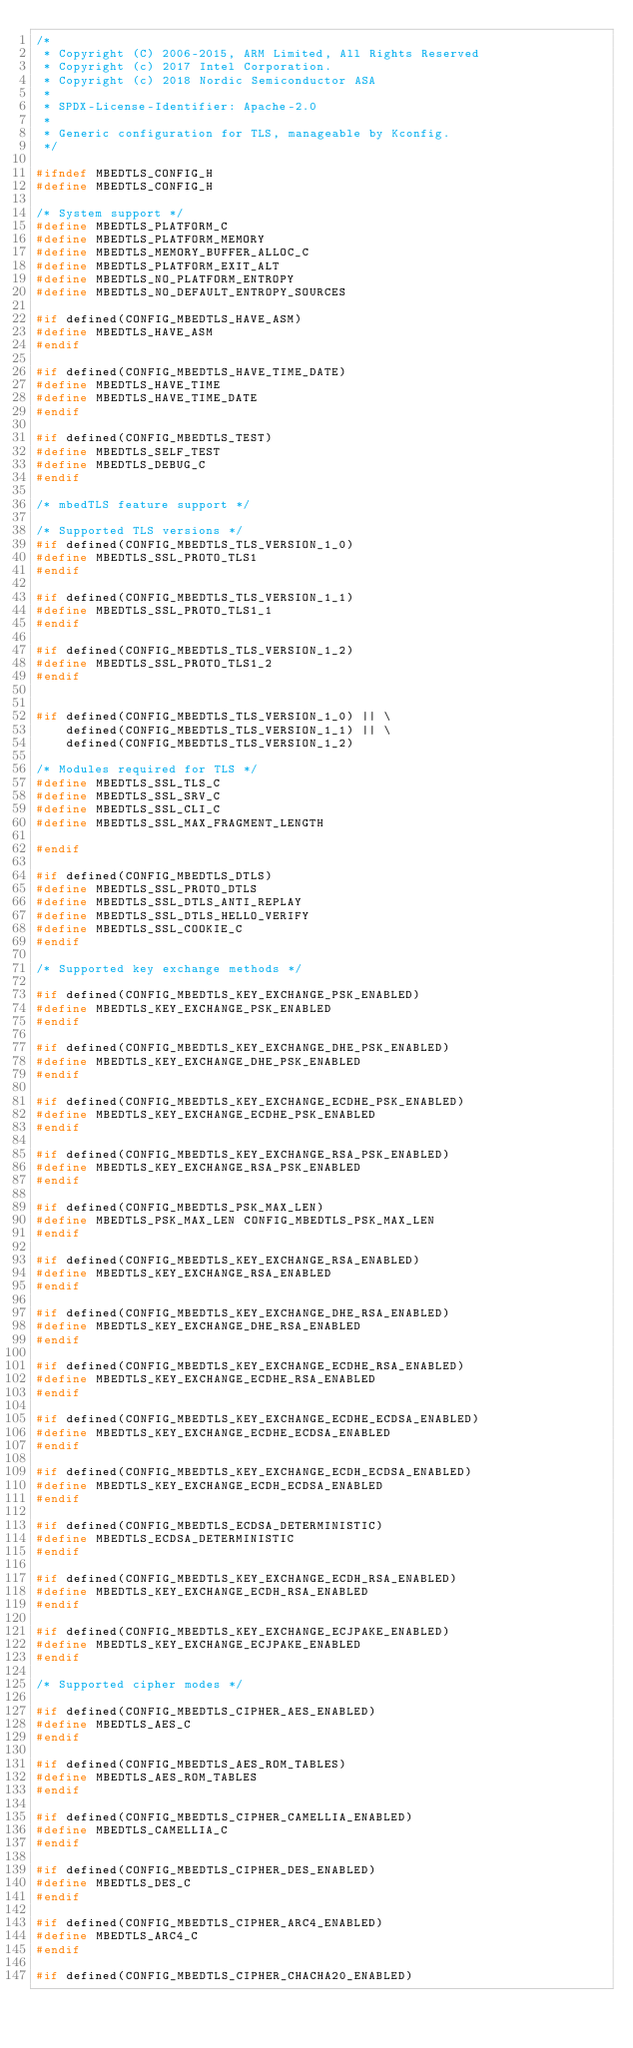Convert code to text. <code><loc_0><loc_0><loc_500><loc_500><_C_>/*
 * Copyright (C) 2006-2015, ARM Limited, All Rights Reserved
 * Copyright (c) 2017 Intel Corporation.
 * Copyright (c) 2018 Nordic Semiconductor ASA
 *
 * SPDX-License-Identifier: Apache-2.0
 *
 * Generic configuration for TLS, manageable by Kconfig.
 */

#ifndef MBEDTLS_CONFIG_H
#define MBEDTLS_CONFIG_H

/* System support */
#define MBEDTLS_PLATFORM_C
#define MBEDTLS_PLATFORM_MEMORY
#define MBEDTLS_MEMORY_BUFFER_ALLOC_C
#define MBEDTLS_PLATFORM_EXIT_ALT
#define MBEDTLS_NO_PLATFORM_ENTROPY
#define MBEDTLS_NO_DEFAULT_ENTROPY_SOURCES

#if defined(CONFIG_MBEDTLS_HAVE_ASM)
#define MBEDTLS_HAVE_ASM
#endif

#if defined(CONFIG_MBEDTLS_HAVE_TIME_DATE)
#define MBEDTLS_HAVE_TIME
#define MBEDTLS_HAVE_TIME_DATE
#endif

#if defined(CONFIG_MBEDTLS_TEST)
#define MBEDTLS_SELF_TEST
#define MBEDTLS_DEBUG_C
#endif

/* mbedTLS feature support */

/* Supported TLS versions */
#if defined(CONFIG_MBEDTLS_TLS_VERSION_1_0)
#define MBEDTLS_SSL_PROTO_TLS1
#endif

#if defined(CONFIG_MBEDTLS_TLS_VERSION_1_1)
#define MBEDTLS_SSL_PROTO_TLS1_1
#endif

#if defined(CONFIG_MBEDTLS_TLS_VERSION_1_2)
#define MBEDTLS_SSL_PROTO_TLS1_2
#endif


#if defined(CONFIG_MBEDTLS_TLS_VERSION_1_0) || \
    defined(CONFIG_MBEDTLS_TLS_VERSION_1_1) || \
    defined(CONFIG_MBEDTLS_TLS_VERSION_1_2)

/* Modules required for TLS */
#define MBEDTLS_SSL_TLS_C
#define MBEDTLS_SSL_SRV_C
#define MBEDTLS_SSL_CLI_C
#define MBEDTLS_SSL_MAX_FRAGMENT_LENGTH

#endif

#if defined(CONFIG_MBEDTLS_DTLS)
#define MBEDTLS_SSL_PROTO_DTLS
#define MBEDTLS_SSL_DTLS_ANTI_REPLAY
#define MBEDTLS_SSL_DTLS_HELLO_VERIFY
#define MBEDTLS_SSL_COOKIE_C
#endif

/* Supported key exchange methods */

#if defined(CONFIG_MBEDTLS_KEY_EXCHANGE_PSK_ENABLED)
#define MBEDTLS_KEY_EXCHANGE_PSK_ENABLED
#endif

#if defined(CONFIG_MBEDTLS_KEY_EXCHANGE_DHE_PSK_ENABLED)
#define MBEDTLS_KEY_EXCHANGE_DHE_PSK_ENABLED
#endif

#if defined(CONFIG_MBEDTLS_KEY_EXCHANGE_ECDHE_PSK_ENABLED)
#define MBEDTLS_KEY_EXCHANGE_ECDHE_PSK_ENABLED
#endif

#if defined(CONFIG_MBEDTLS_KEY_EXCHANGE_RSA_PSK_ENABLED)
#define MBEDTLS_KEY_EXCHANGE_RSA_PSK_ENABLED
#endif

#if defined(CONFIG_MBEDTLS_PSK_MAX_LEN)
#define MBEDTLS_PSK_MAX_LEN	CONFIG_MBEDTLS_PSK_MAX_LEN
#endif

#if defined(CONFIG_MBEDTLS_KEY_EXCHANGE_RSA_ENABLED)
#define MBEDTLS_KEY_EXCHANGE_RSA_ENABLED
#endif

#if defined(CONFIG_MBEDTLS_KEY_EXCHANGE_DHE_RSA_ENABLED)
#define MBEDTLS_KEY_EXCHANGE_DHE_RSA_ENABLED
#endif

#if defined(CONFIG_MBEDTLS_KEY_EXCHANGE_ECDHE_RSA_ENABLED)
#define MBEDTLS_KEY_EXCHANGE_ECDHE_RSA_ENABLED
#endif

#if defined(CONFIG_MBEDTLS_KEY_EXCHANGE_ECDHE_ECDSA_ENABLED)
#define MBEDTLS_KEY_EXCHANGE_ECDHE_ECDSA_ENABLED
#endif

#if defined(CONFIG_MBEDTLS_KEY_EXCHANGE_ECDH_ECDSA_ENABLED)
#define MBEDTLS_KEY_EXCHANGE_ECDH_ECDSA_ENABLED
#endif

#if defined(CONFIG_MBEDTLS_ECDSA_DETERMINISTIC)
#define MBEDTLS_ECDSA_DETERMINISTIC
#endif

#if defined(CONFIG_MBEDTLS_KEY_EXCHANGE_ECDH_RSA_ENABLED)
#define MBEDTLS_KEY_EXCHANGE_ECDH_RSA_ENABLED
#endif

#if defined(CONFIG_MBEDTLS_KEY_EXCHANGE_ECJPAKE_ENABLED)
#define MBEDTLS_KEY_EXCHANGE_ECJPAKE_ENABLED
#endif

/* Supported cipher modes */

#if defined(CONFIG_MBEDTLS_CIPHER_AES_ENABLED)
#define MBEDTLS_AES_C
#endif

#if defined(CONFIG_MBEDTLS_AES_ROM_TABLES)
#define MBEDTLS_AES_ROM_TABLES
#endif

#if defined(CONFIG_MBEDTLS_CIPHER_CAMELLIA_ENABLED)
#define MBEDTLS_CAMELLIA_C
#endif

#if defined(CONFIG_MBEDTLS_CIPHER_DES_ENABLED)
#define MBEDTLS_DES_C
#endif

#if defined(CONFIG_MBEDTLS_CIPHER_ARC4_ENABLED)
#define MBEDTLS_ARC4_C
#endif

#if defined(CONFIG_MBEDTLS_CIPHER_CHACHA20_ENABLED)</code> 